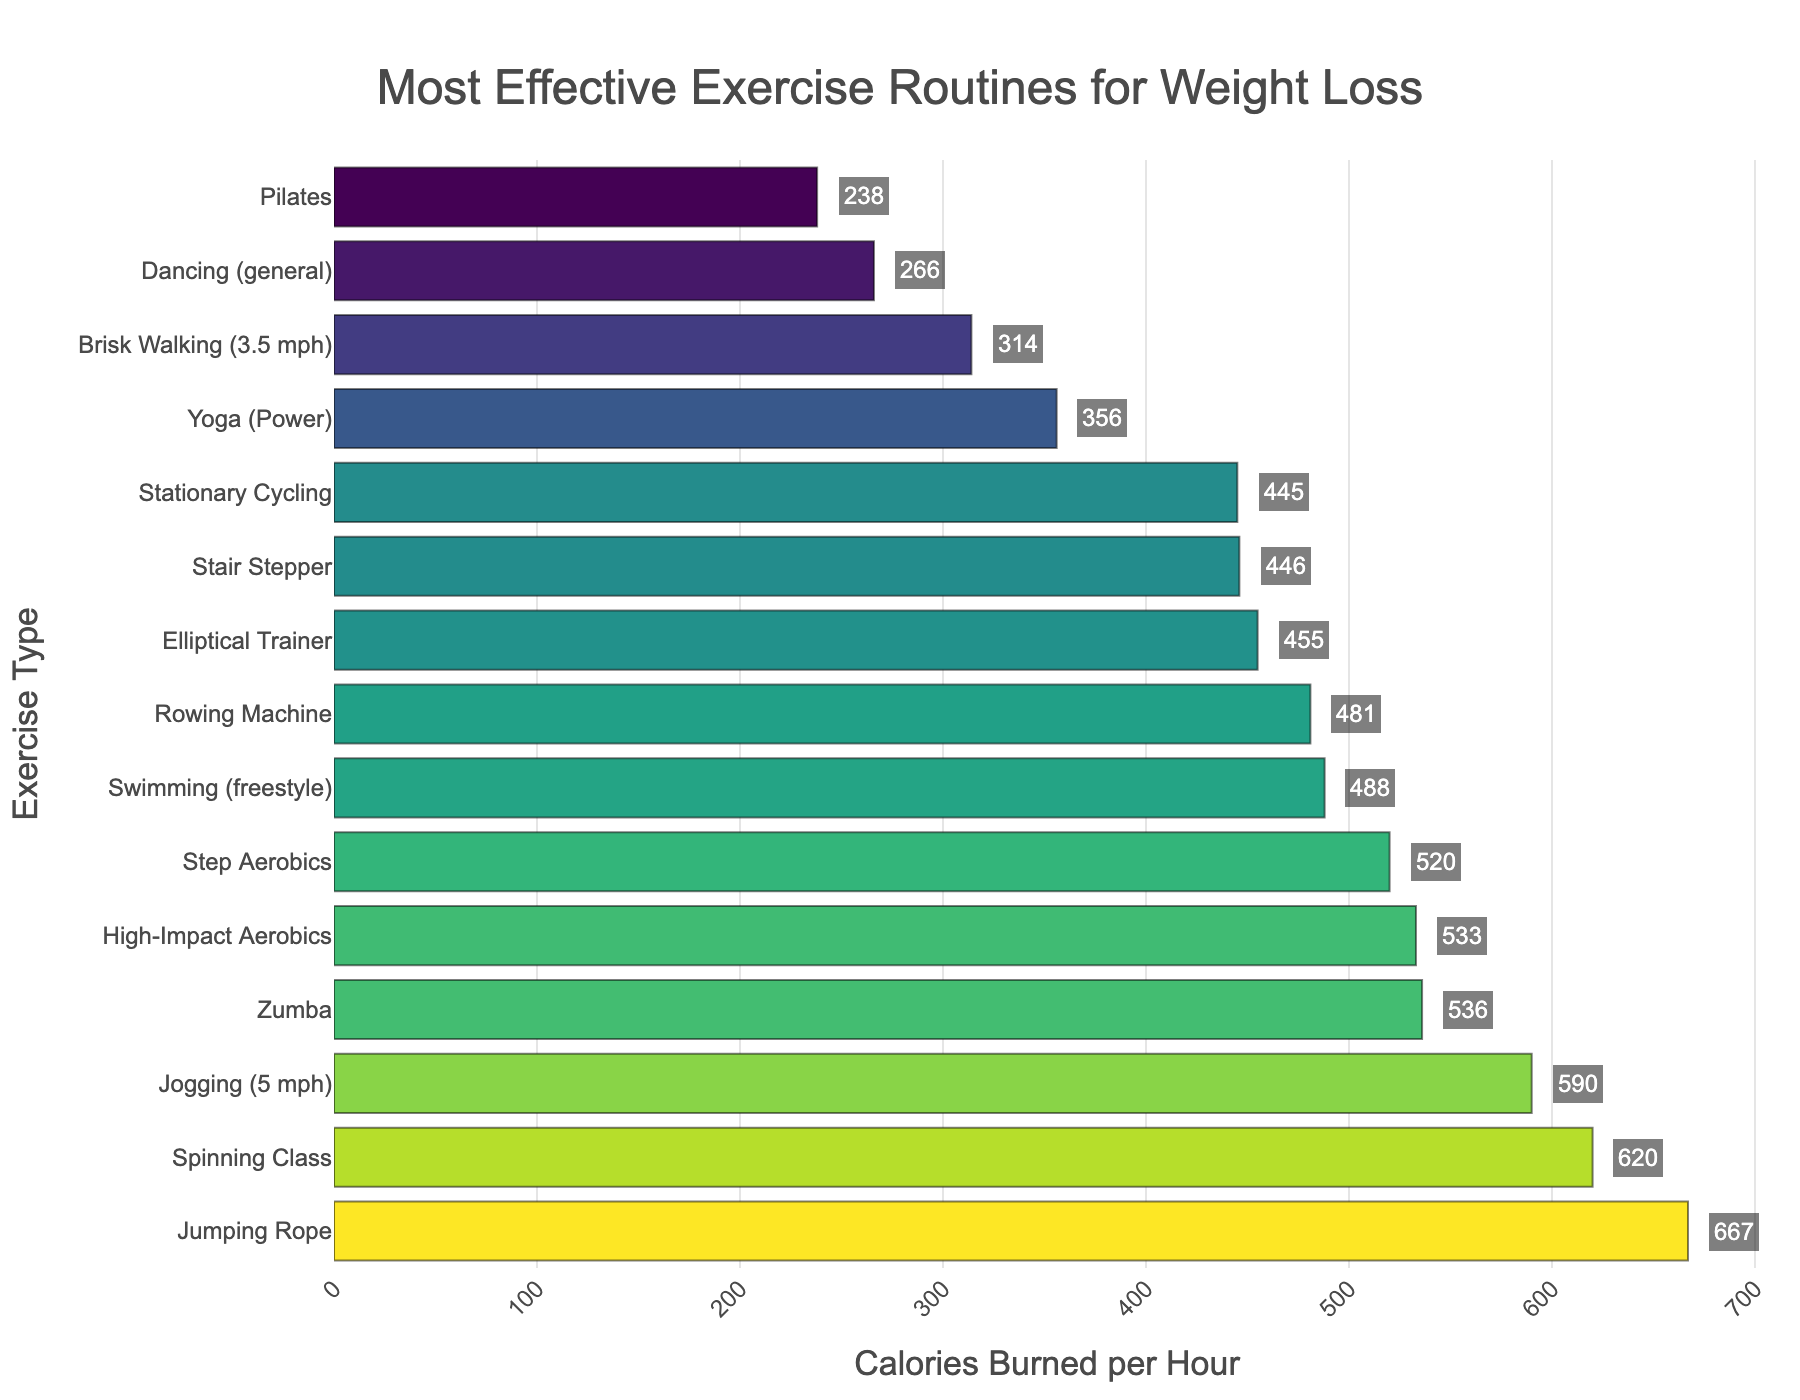What's the most effective exercise routine for burning calories? The bar all the way on the top represents the exercise routine with the highest calories burned per hour. In this case, it's Jumping Rope, with 667 calories burned per hour.
Answer: Jumping Rope Which exercise actually burns fewer calories, Brisk Walking or Pilates? We compare the positions relative to each other. Brisk Walking burns 314 calories per hour while Pilates burns 238 calories per hour. Hence, Pilates burns fewer calories.
Answer: Pilates How many more calories does Yoga (Power) burn compared to Dancing (general)? Look at the values for Yoga (Power) and Dancing (general). Yoga (Power) burns 356 calories per hour and Dancing (general) burns 266 calories per hour. The difference is 356 - 266 = 90.
Answer: 90 What is the combined total of calories burned by Swimming (freestyle) and Rowing Machine? Get the values for each and sum them. Swimming (freestyle) burns 488 calories per hour while Rowing Machine burns 481. The combined total is 488 + 481 = 969.
Answer: 969 Is Spinning Class more effective than Step Aerobics in terms of calorie burning? We compare the number for each exercise. Spinning Class burns 620 calories per hour while Step Aerobics burns 520 calories per hour. Therefore, Spinning Class is more effective.
Answer: Yes What's the average number of calories burned per hour for the following exercises: High-Impact Aerobics, Zumba, and Yoga (Power)? Sum the calories burned for each exercise and then divide by the number of exercises. High-Impact Aerobics burns 533, Zumba burns 536, and Yoga (Power) burns 356. The total is 533 + 536 + 356 = 1425. The average is 1425 / 3 ≈ 475.
Answer: 475 Which exercise burns more calories, Jogging (5 mph) or Elliptical Trainer? Check the bar lengths or the actual values. Jogging (5 mph) burns 590 calories per hour while the Elliptical Trainer burns 455 calories per hour. Therefore, Jogging (5 mph) burns more calories.
Answer: Jogging (5 mph) How many calories in total are burned by Stationary Cycling, step Aerobics, and Stair Stepper workouts? Add the calories burned for each. Stationary Cycling burns 445, Step Aerobics burns 520, and Stair Stepper burns 446. The total is 445 + 520 + 446 = 1411.
Answer: 1411 